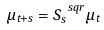<formula> <loc_0><loc_0><loc_500><loc_500>\mu _ { t + s } = S _ { s } ^ { \ s q r } \mu _ { t }</formula> 